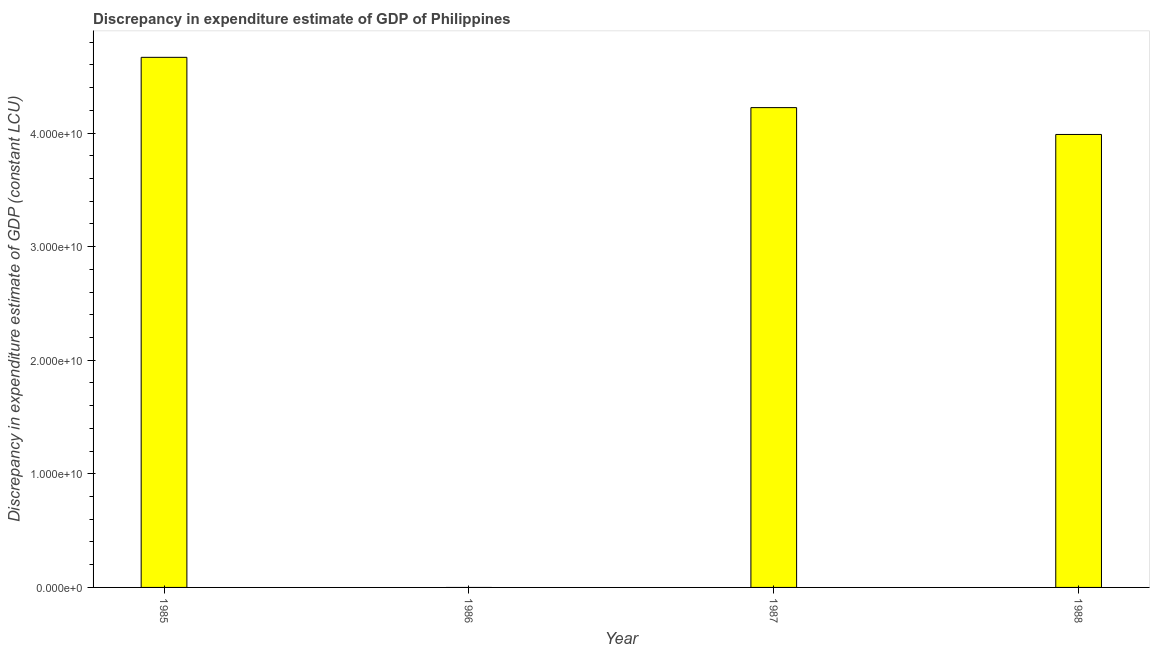Does the graph contain grids?
Make the answer very short. No. What is the title of the graph?
Keep it short and to the point. Discrepancy in expenditure estimate of GDP of Philippines. What is the label or title of the Y-axis?
Provide a succinct answer. Discrepancy in expenditure estimate of GDP (constant LCU). Across all years, what is the maximum discrepancy in expenditure estimate of gdp?
Your answer should be very brief. 4.67e+1. What is the sum of the discrepancy in expenditure estimate of gdp?
Provide a succinct answer. 1.29e+11. What is the difference between the discrepancy in expenditure estimate of gdp in 1985 and 1987?
Your answer should be compact. 4.43e+09. What is the average discrepancy in expenditure estimate of gdp per year?
Your answer should be very brief. 3.22e+1. What is the median discrepancy in expenditure estimate of gdp?
Provide a succinct answer. 4.11e+1. What is the ratio of the discrepancy in expenditure estimate of gdp in 1985 to that in 1988?
Keep it short and to the point. 1.17. Is the difference between the discrepancy in expenditure estimate of gdp in 1985 and 1988 greater than the difference between any two years?
Your answer should be compact. No. What is the difference between the highest and the second highest discrepancy in expenditure estimate of gdp?
Your answer should be very brief. 4.43e+09. What is the difference between the highest and the lowest discrepancy in expenditure estimate of gdp?
Give a very brief answer. 4.67e+1. In how many years, is the discrepancy in expenditure estimate of gdp greater than the average discrepancy in expenditure estimate of gdp taken over all years?
Provide a succinct answer. 3. Are the values on the major ticks of Y-axis written in scientific E-notation?
Your response must be concise. Yes. What is the Discrepancy in expenditure estimate of GDP (constant LCU) of 1985?
Your response must be concise. 4.67e+1. What is the Discrepancy in expenditure estimate of GDP (constant LCU) in 1987?
Your answer should be compact. 4.22e+1. What is the Discrepancy in expenditure estimate of GDP (constant LCU) of 1988?
Provide a short and direct response. 3.99e+1. What is the difference between the Discrepancy in expenditure estimate of GDP (constant LCU) in 1985 and 1987?
Make the answer very short. 4.43e+09. What is the difference between the Discrepancy in expenditure estimate of GDP (constant LCU) in 1985 and 1988?
Your response must be concise. 6.79e+09. What is the difference between the Discrepancy in expenditure estimate of GDP (constant LCU) in 1987 and 1988?
Your response must be concise. 2.36e+09. What is the ratio of the Discrepancy in expenditure estimate of GDP (constant LCU) in 1985 to that in 1987?
Keep it short and to the point. 1.1. What is the ratio of the Discrepancy in expenditure estimate of GDP (constant LCU) in 1985 to that in 1988?
Ensure brevity in your answer.  1.17. What is the ratio of the Discrepancy in expenditure estimate of GDP (constant LCU) in 1987 to that in 1988?
Offer a terse response. 1.06. 